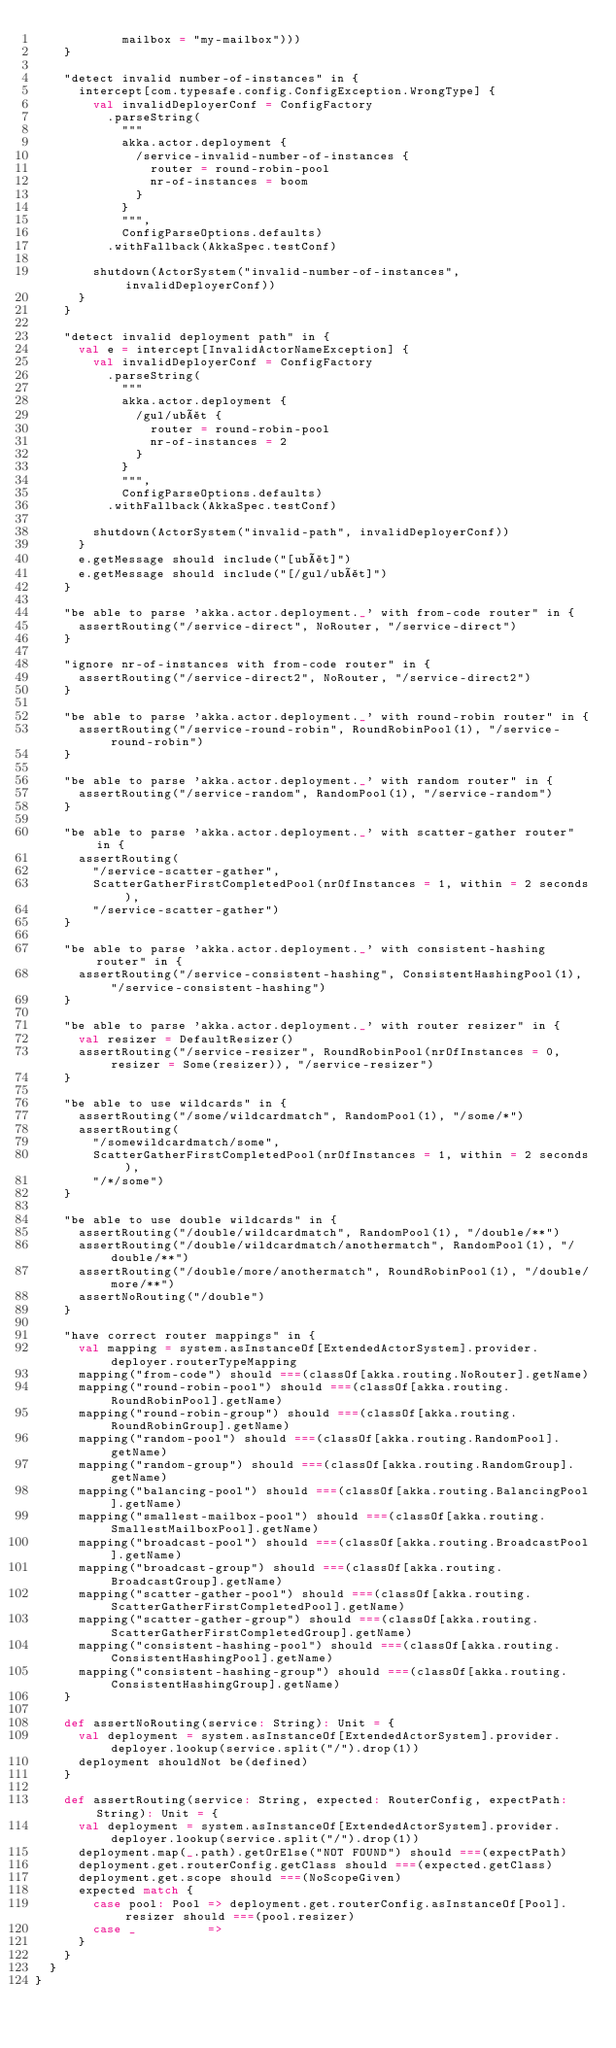<code> <loc_0><loc_0><loc_500><loc_500><_Scala_>            mailbox = "my-mailbox")))
    }

    "detect invalid number-of-instances" in {
      intercept[com.typesafe.config.ConfigException.WrongType] {
        val invalidDeployerConf = ConfigFactory
          .parseString(
            """
            akka.actor.deployment {
              /service-invalid-number-of-instances {
                router = round-robin-pool
                nr-of-instances = boom
              }
            }
            """,
            ConfigParseOptions.defaults)
          .withFallback(AkkaSpec.testConf)

        shutdown(ActorSystem("invalid-number-of-instances", invalidDeployerConf))
      }
    }

    "detect invalid deployment path" in {
      val e = intercept[InvalidActorNameException] {
        val invalidDeployerConf = ConfigFactory
          .parseString(
            """
            akka.actor.deployment {
              /gul/ubåt {
                router = round-robin-pool
                nr-of-instances = 2
              }
            }
            """,
            ConfigParseOptions.defaults)
          .withFallback(AkkaSpec.testConf)

        shutdown(ActorSystem("invalid-path", invalidDeployerConf))
      }
      e.getMessage should include("[ubåt]")
      e.getMessage should include("[/gul/ubåt]")
    }

    "be able to parse 'akka.actor.deployment._' with from-code router" in {
      assertRouting("/service-direct", NoRouter, "/service-direct")
    }

    "ignore nr-of-instances with from-code router" in {
      assertRouting("/service-direct2", NoRouter, "/service-direct2")
    }

    "be able to parse 'akka.actor.deployment._' with round-robin router" in {
      assertRouting("/service-round-robin", RoundRobinPool(1), "/service-round-robin")
    }

    "be able to parse 'akka.actor.deployment._' with random router" in {
      assertRouting("/service-random", RandomPool(1), "/service-random")
    }

    "be able to parse 'akka.actor.deployment._' with scatter-gather router" in {
      assertRouting(
        "/service-scatter-gather",
        ScatterGatherFirstCompletedPool(nrOfInstances = 1, within = 2 seconds),
        "/service-scatter-gather")
    }

    "be able to parse 'akka.actor.deployment._' with consistent-hashing router" in {
      assertRouting("/service-consistent-hashing", ConsistentHashingPool(1), "/service-consistent-hashing")
    }

    "be able to parse 'akka.actor.deployment._' with router resizer" in {
      val resizer = DefaultResizer()
      assertRouting("/service-resizer", RoundRobinPool(nrOfInstances = 0, resizer = Some(resizer)), "/service-resizer")
    }

    "be able to use wildcards" in {
      assertRouting("/some/wildcardmatch", RandomPool(1), "/some/*")
      assertRouting(
        "/somewildcardmatch/some",
        ScatterGatherFirstCompletedPool(nrOfInstances = 1, within = 2 seconds),
        "/*/some")
    }

    "be able to use double wildcards" in {
      assertRouting("/double/wildcardmatch", RandomPool(1), "/double/**")
      assertRouting("/double/wildcardmatch/anothermatch", RandomPool(1), "/double/**")
      assertRouting("/double/more/anothermatch", RoundRobinPool(1), "/double/more/**")
      assertNoRouting("/double")
    }

    "have correct router mappings" in {
      val mapping = system.asInstanceOf[ExtendedActorSystem].provider.deployer.routerTypeMapping
      mapping("from-code") should ===(classOf[akka.routing.NoRouter].getName)
      mapping("round-robin-pool") should ===(classOf[akka.routing.RoundRobinPool].getName)
      mapping("round-robin-group") should ===(classOf[akka.routing.RoundRobinGroup].getName)
      mapping("random-pool") should ===(classOf[akka.routing.RandomPool].getName)
      mapping("random-group") should ===(classOf[akka.routing.RandomGroup].getName)
      mapping("balancing-pool") should ===(classOf[akka.routing.BalancingPool].getName)
      mapping("smallest-mailbox-pool") should ===(classOf[akka.routing.SmallestMailboxPool].getName)
      mapping("broadcast-pool") should ===(classOf[akka.routing.BroadcastPool].getName)
      mapping("broadcast-group") should ===(classOf[akka.routing.BroadcastGroup].getName)
      mapping("scatter-gather-pool") should ===(classOf[akka.routing.ScatterGatherFirstCompletedPool].getName)
      mapping("scatter-gather-group") should ===(classOf[akka.routing.ScatterGatherFirstCompletedGroup].getName)
      mapping("consistent-hashing-pool") should ===(classOf[akka.routing.ConsistentHashingPool].getName)
      mapping("consistent-hashing-group") should ===(classOf[akka.routing.ConsistentHashingGroup].getName)
    }

    def assertNoRouting(service: String): Unit = {
      val deployment = system.asInstanceOf[ExtendedActorSystem].provider.deployer.lookup(service.split("/").drop(1))
      deployment shouldNot be(defined)
    }

    def assertRouting(service: String, expected: RouterConfig, expectPath: String): Unit = {
      val deployment = system.asInstanceOf[ExtendedActorSystem].provider.deployer.lookup(service.split("/").drop(1))
      deployment.map(_.path).getOrElse("NOT FOUND") should ===(expectPath)
      deployment.get.routerConfig.getClass should ===(expected.getClass)
      deployment.get.scope should ===(NoScopeGiven)
      expected match {
        case pool: Pool => deployment.get.routerConfig.asInstanceOf[Pool].resizer should ===(pool.resizer)
        case _          =>
      }
    }
  }
}
</code> 